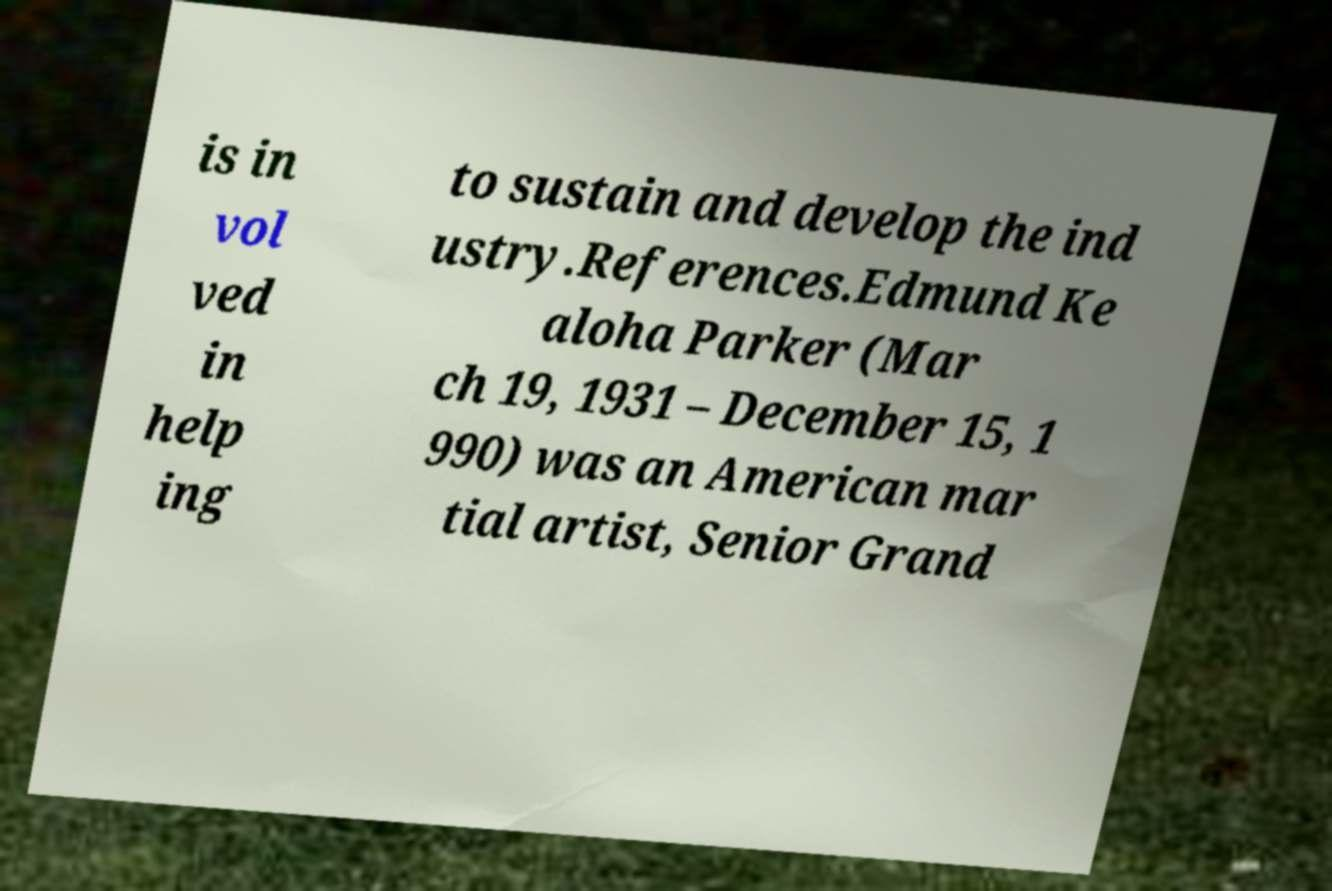Please read and relay the text visible in this image. What does it say? is in vol ved in help ing to sustain and develop the ind ustry.References.Edmund Ke aloha Parker (Mar ch 19, 1931 – December 15, 1 990) was an American mar tial artist, Senior Grand 